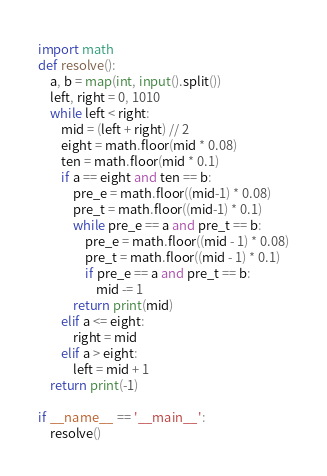<code> <loc_0><loc_0><loc_500><loc_500><_Python_>import math
def resolve():
    a, b = map(int, input().split())
    left, right = 0, 1010
    while left < right:
        mid = (left + right) // 2
        eight = math.floor(mid * 0.08)
        ten = math.floor(mid * 0.1)
        if a == eight and ten == b:
            pre_e = math.floor((mid-1) * 0.08)
            pre_t = math.floor((mid-1) * 0.1)
            while pre_e == a and pre_t == b:
                pre_e = math.floor((mid - 1) * 0.08)
                pre_t = math.floor((mid - 1) * 0.1)
                if pre_e == a and pre_t == b:
                    mid -= 1
            return print(mid)
        elif a <= eight:
            right = mid
        elif a > eight:
            left = mid + 1
    return print(-1)

if __name__ == '__main__':
    resolve()
</code> 